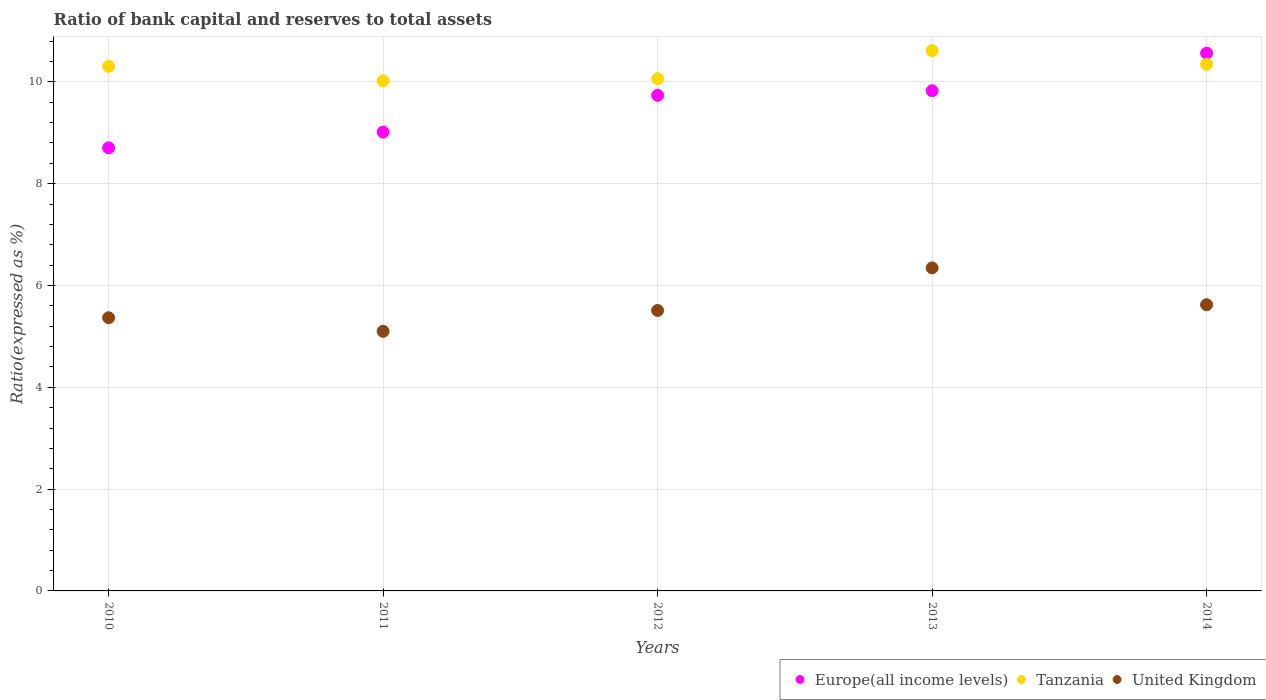Is the number of dotlines equal to the number of legend labels?
Provide a short and direct response. Yes. What is the ratio of bank capital and reserves to total assets in Europe(all income levels) in 2010?
Ensure brevity in your answer.  8.7. Across all years, what is the maximum ratio of bank capital and reserves to total assets in United Kingdom?
Make the answer very short. 6.35. Across all years, what is the minimum ratio of bank capital and reserves to total assets in Europe(all income levels)?
Provide a succinct answer. 8.7. In which year was the ratio of bank capital and reserves to total assets in United Kingdom maximum?
Offer a very short reply. 2013. In which year was the ratio of bank capital and reserves to total assets in Tanzania minimum?
Your answer should be very brief. 2011. What is the total ratio of bank capital and reserves to total assets in Europe(all income levels) in the graph?
Give a very brief answer. 47.84. What is the difference between the ratio of bank capital and reserves to total assets in Tanzania in 2010 and that in 2012?
Ensure brevity in your answer.  0.24. What is the difference between the ratio of bank capital and reserves to total assets in Tanzania in 2011 and the ratio of bank capital and reserves to total assets in United Kingdom in 2014?
Offer a terse response. 4.4. What is the average ratio of bank capital and reserves to total assets in Tanzania per year?
Offer a terse response. 10.27. In the year 2013, what is the difference between the ratio of bank capital and reserves to total assets in Tanzania and ratio of bank capital and reserves to total assets in United Kingdom?
Give a very brief answer. 4.27. What is the ratio of the ratio of bank capital and reserves to total assets in Europe(all income levels) in 2011 to that in 2012?
Give a very brief answer. 0.93. Is the difference between the ratio of bank capital and reserves to total assets in Tanzania in 2010 and 2013 greater than the difference between the ratio of bank capital and reserves to total assets in United Kingdom in 2010 and 2013?
Make the answer very short. Yes. What is the difference between the highest and the second highest ratio of bank capital and reserves to total assets in Tanzania?
Make the answer very short. 0.27. What is the difference between the highest and the lowest ratio of bank capital and reserves to total assets in Tanzania?
Your response must be concise. 0.59. In how many years, is the ratio of bank capital and reserves to total assets in Tanzania greater than the average ratio of bank capital and reserves to total assets in Tanzania taken over all years?
Provide a succinct answer. 3. Is the sum of the ratio of bank capital and reserves to total assets in Tanzania in 2012 and 2014 greater than the maximum ratio of bank capital and reserves to total assets in Europe(all income levels) across all years?
Ensure brevity in your answer.  Yes. Is it the case that in every year, the sum of the ratio of bank capital and reserves to total assets in Europe(all income levels) and ratio of bank capital and reserves to total assets in Tanzania  is greater than the ratio of bank capital and reserves to total assets in United Kingdom?
Your answer should be very brief. Yes. How many dotlines are there?
Offer a terse response. 3. How many years are there in the graph?
Your answer should be very brief. 5. Does the graph contain any zero values?
Offer a very short reply. No. How many legend labels are there?
Offer a very short reply. 3. What is the title of the graph?
Keep it short and to the point. Ratio of bank capital and reserves to total assets. What is the label or title of the Y-axis?
Keep it short and to the point. Ratio(expressed as %). What is the Ratio(expressed as %) in Europe(all income levels) in 2010?
Ensure brevity in your answer.  8.7. What is the Ratio(expressed as %) of Tanzania in 2010?
Ensure brevity in your answer.  10.3. What is the Ratio(expressed as %) in United Kingdom in 2010?
Offer a very short reply. 5.37. What is the Ratio(expressed as %) in Europe(all income levels) in 2011?
Ensure brevity in your answer.  9.01. What is the Ratio(expressed as %) of Tanzania in 2011?
Provide a succinct answer. 10.02. What is the Ratio(expressed as %) in United Kingdom in 2011?
Provide a succinct answer. 5.1. What is the Ratio(expressed as %) in Europe(all income levels) in 2012?
Ensure brevity in your answer.  9.74. What is the Ratio(expressed as %) of Tanzania in 2012?
Provide a short and direct response. 10.06. What is the Ratio(expressed as %) of United Kingdom in 2012?
Offer a terse response. 5.51. What is the Ratio(expressed as %) of Europe(all income levels) in 2013?
Ensure brevity in your answer.  9.83. What is the Ratio(expressed as %) in Tanzania in 2013?
Give a very brief answer. 10.61. What is the Ratio(expressed as %) in United Kingdom in 2013?
Your response must be concise. 6.35. What is the Ratio(expressed as %) in Europe(all income levels) in 2014?
Offer a very short reply. 10.56. What is the Ratio(expressed as %) in Tanzania in 2014?
Your answer should be very brief. 10.35. What is the Ratio(expressed as %) of United Kingdom in 2014?
Ensure brevity in your answer.  5.62. Across all years, what is the maximum Ratio(expressed as %) of Europe(all income levels)?
Make the answer very short. 10.56. Across all years, what is the maximum Ratio(expressed as %) of Tanzania?
Offer a very short reply. 10.61. Across all years, what is the maximum Ratio(expressed as %) in United Kingdom?
Provide a short and direct response. 6.35. Across all years, what is the minimum Ratio(expressed as %) in Europe(all income levels)?
Keep it short and to the point. 8.7. Across all years, what is the minimum Ratio(expressed as %) of Tanzania?
Provide a succinct answer. 10.02. Across all years, what is the minimum Ratio(expressed as %) in United Kingdom?
Keep it short and to the point. 5.1. What is the total Ratio(expressed as %) of Europe(all income levels) in the graph?
Your answer should be very brief. 47.84. What is the total Ratio(expressed as %) in Tanzania in the graph?
Give a very brief answer. 51.35. What is the total Ratio(expressed as %) in United Kingdom in the graph?
Offer a terse response. 27.94. What is the difference between the Ratio(expressed as %) in Europe(all income levels) in 2010 and that in 2011?
Provide a succinct answer. -0.31. What is the difference between the Ratio(expressed as %) of Tanzania in 2010 and that in 2011?
Your answer should be compact. 0.28. What is the difference between the Ratio(expressed as %) of United Kingdom in 2010 and that in 2011?
Give a very brief answer. 0.27. What is the difference between the Ratio(expressed as %) of Europe(all income levels) in 2010 and that in 2012?
Your answer should be compact. -1.03. What is the difference between the Ratio(expressed as %) in Tanzania in 2010 and that in 2012?
Keep it short and to the point. 0.24. What is the difference between the Ratio(expressed as %) in United Kingdom in 2010 and that in 2012?
Give a very brief answer. -0.14. What is the difference between the Ratio(expressed as %) in Europe(all income levels) in 2010 and that in 2013?
Offer a very short reply. -1.12. What is the difference between the Ratio(expressed as %) of Tanzania in 2010 and that in 2013?
Provide a succinct answer. -0.31. What is the difference between the Ratio(expressed as %) of United Kingdom in 2010 and that in 2013?
Provide a short and direct response. -0.98. What is the difference between the Ratio(expressed as %) of Europe(all income levels) in 2010 and that in 2014?
Give a very brief answer. -1.86. What is the difference between the Ratio(expressed as %) of Tanzania in 2010 and that in 2014?
Offer a terse response. -0.04. What is the difference between the Ratio(expressed as %) in United Kingdom in 2010 and that in 2014?
Offer a terse response. -0.26. What is the difference between the Ratio(expressed as %) of Europe(all income levels) in 2011 and that in 2012?
Provide a short and direct response. -0.72. What is the difference between the Ratio(expressed as %) of Tanzania in 2011 and that in 2012?
Give a very brief answer. -0.04. What is the difference between the Ratio(expressed as %) in United Kingdom in 2011 and that in 2012?
Provide a succinct answer. -0.41. What is the difference between the Ratio(expressed as %) of Europe(all income levels) in 2011 and that in 2013?
Make the answer very short. -0.81. What is the difference between the Ratio(expressed as %) of Tanzania in 2011 and that in 2013?
Keep it short and to the point. -0.59. What is the difference between the Ratio(expressed as %) of United Kingdom in 2011 and that in 2013?
Provide a short and direct response. -1.25. What is the difference between the Ratio(expressed as %) in Europe(all income levels) in 2011 and that in 2014?
Your response must be concise. -1.55. What is the difference between the Ratio(expressed as %) in Tanzania in 2011 and that in 2014?
Give a very brief answer. -0.33. What is the difference between the Ratio(expressed as %) in United Kingdom in 2011 and that in 2014?
Offer a terse response. -0.52. What is the difference between the Ratio(expressed as %) in Europe(all income levels) in 2012 and that in 2013?
Make the answer very short. -0.09. What is the difference between the Ratio(expressed as %) of Tanzania in 2012 and that in 2013?
Your response must be concise. -0.55. What is the difference between the Ratio(expressed as %) of United Kingdom in 2012 and that in 2013?
Give a very brief answer. -0.84. What is the difference between the Ratio(expressed as %) of Europe(all income levels) in 2012 and that in 2014?
Provide a succinct answer. -0.83. What is the difference between the Ratio(expressed as %) of Tanzania in 2012 and that in 2014?
Give a very brief answer. -0.28. What is the difference between the Ratio(expressed as %) in United Kingdom in 2012 and that in 2014?
Offer a terse response. -0.11. What is the difference between the Ratio(expressed as %) of Europe(all income levels) in 2013 and that in 2014?
Provide a succinct answer. -0.74. What is the difference between the Ratio(expressed as %) in Tanzania in 2013 and that in 2014?
Make the answer very short. 0.27. What is the difference between the Ratio(expressed as %) of United Kingdom in 2013 and that in 2014?
Provide a short and direct response. 0.72. What is the difference between the Ratio(expressed as %) in Europe(all income levels) in 2010 and the Ratio(expressed as %) in Tanzania in 2011?
Your answer should be very brief. -1.32. What is the difference between the Ratio(expressed as %) of Europe(all income levels) in 2010 and the Ratio(expressed as %) of United Kingdom in 2011?
Give a very brief answer. 3.6. What is the difference between the Ratio(expressed as %) of Tanzania in 2010 and the Ratio(expressed as %) of United Kingdom in 2011?
Ensure brevity in your answer.  5.2. What is the difference between the Ratio(expressed as %) in Europe(all income levels) in 2010 and the Ratio(expressed as %) in Tanzania in 2012?
Provide a succinct answer. -1.36. What is the difference between the Ratio(expressed as %) of Europe(all income levels) in 2010 and the Ratio(expressed as %) of United Kingdom in 2012?
Offer a very short reply. 3.2. What is the difference between the Ratio(expressed as %) in Tanzania in 2010 and the Ratio(expressed as %) in United Kingdom in 2012?
Offer a terse response. 4.8. What is the difference between the Ratio(expressed as %) of Europe(all income levels) in 2010 and the Ratio(expressed as %) of Tanzania in 2013?
Provide a succinct answer. -1.91. What is the difference between the Ratio(expressed as %) of Europe(all income levels) in 2010 and the Ratio(expressed as %) of United Kingdom in 2013?
Your response must be concise. 2.36. What is the difference between the Ratio(expressed as %) of Tanzania in 2010 and the Ratio(expressed as %) of United Kingdom in 2013?
Provide a succinct answer. 3.96. What is the difference between the Ratio(expressed as %) of Europe(all income levels) in 2010 and the Ratio(expressed as %) of Tanzania in 2014?
Provide a succinct answer. -1.64. What is the difference between the Ratio(expressed as %) of Europe(all income levels) in 2010 and the Ratio(expressed as %) of United Kingdom in 2014?
Offer a terse response. 3.08. What is the difference between the Ratio(expressed as %) of Tanzania in 2010 and the Ratio(expressed as %) of United Kingdom in 2014?
Your answer should be compact. 4.68. What is the difference between the Ratio(expressed as %) in Europe(all income levels) in 2011 and the Ratio(expressed as %) in Tanzania in 2012?
Provide a short and direct response. -1.05. What is the difference between the Ratio(expressed as %) in Europe(all income levels) in 2011 and the Ratio(expressed as %) in United Kingdom in 2012?
Your answer should be compact. 3.5. What is the difference between the Ratio(expressed as %) in Tanzania in 2011 and the Ratio(expressed as %) in United Kingdom in 2012?
Provide a short and direct response. 4.51. What is the difference between the Ratio(expressed as %) in Europe(all income levels) in 2011 and the Ratio(expressed as %) in Tanzania in 2013?
Your response must be concise. -1.6. What is the difference between the Ratio(expressed as %) in Europe(all income levels) in 2011 and the Ratio(expressed as %) in United Kingdom in 2013?
Make the answer very short. 2.67. What is the difference between the Ratio(expressed as %) in Tanzania in 2011 and the Ratio(expressed as %) in United Kingdom in 2013?
Give a very brief answer. 3.67. What is the difference between the Ratio(expressed as %) in Europe(all income levels) in 2011 and the Ratio(expressed as %) in Tanzania in 2014?
Keep it short and to the point. -1.33. What is the difference between the Ratio(expressed as %) of Europe(all income levels) in 2011 and the Ratio(expressed as %) of United Kingdom in 2014?
Your response must be concise. 3.39. What is the difference between the Ratio(expressed as %) of Tanzania in 2011 and the Ratio(expressed as %) of United Kingdom in 2014?
Give a very brief answer. 4.4. What is the difference between the Ratio(expressed as %) in Europe(all income levels) in 2012 and the Ratio(expressed as %) in Tanzania in 2013?
Provide a short and direct response. -0.88. What is the difference between the Ratio(expressed as %) of Europe(all income levels) in 2012 and the Ratio(expressed as %) of United Kingdom in 2013?
Your answer should be very brief. 3.39. What is the difference between the Ratio(expressed as %) in Tanzania in 2012 and the Ratio(expressed as %) in United Kingdom in 2013?
Provide a short and direct response. 3.72. What is the difference between the Ratio(expressed as %) in Europe(all income levels) in 2012 and the Ratio(expressed as %) in Tanzania in 2014?
Provide a short and direct response. -0.61. What is the difference between the Ratio(expressed as %) in Europe(all income levels) in 2012 and the Ratio(expressed as %) in United Kingdom in 2014?
Your answer should be very brief. 4.11. What is the difference between the Ratio(expressed as %) in Tanzania in 2012 and the Ratio(expressed as %) in United Kingdom in 2014?
Provide a succinct answer. 4.44. What is the difference between the Ratio(expressed as %) of Europe(all income levels) in 2013 and the Ratio(expressed as %) of Tanzania in 2014?
Keep it short and to the point. -0.52. What is the difference between the Ratio(expressed as %) of Europe(all income levels) in 2013 and the Ratio(expressed as %) of United Kingdom in 2014?
Provide a short and direct response. 4.2. What is the difference between the Ratio(expressed as %) in Tanzania in 2013 and the Ratio(expressed as %) in United Kingdom in 2014?
Your answer should be very brief. 4.99. What is the average Ratio(expressed as %) in Europe(all income levels) per year?
Ensure brevity in your answer.  9.57. What is the average Ratio(expressed as %) in Tanzania per year?
Ensure brevity in your answer.  10.27. What is the average Ratio(expressed as %) of United Kingdom per year?
Provide a succinct answer. 5.59. In the year 2010, what is the difference between the Ratio(expressed as %) in Europe(all income levels) and Ratio(expressed as %) in Tanzania?
Keep it short and to the point. -1.6. In the year 2010, what is the difference between the Ratio(expressed as %) in Europe(all income levels) and Ratio(expressed as %) in United Kingdom?
Offer a terse response. 3.34. In the year 2010, what is the difference between the Ratio(expressed as %) of Tanzania and Ratio(expressed as %) of United Kingdom?
Make the answer very short. 4.94. In the year 2011, what is the difference between the Ratio(expressed as %) in Europe(all income levels) and Ratio(expressed as %) in Tanzania?
Offer a very short reply. -1.01. In the year 2011, what is the difference between the Ratio(expressed as %) in Europe(all income levels) and Ratio(expressed as %) in United Kingdom?
Provide a succinct answer. 3.91. In the year 2011, what is the difference between the Ratio(expressed as %) in Tanzania and Ratio(expressed as %) in United Kingdom?
Offer a very short reply. 4.92. In the year 2012, what is the difference between the Ratio(expressed as %) of Europe(all income levels) and Ratio(expressed as %) of Tanzania?
Give a very brief answer. -0.33. In the year 2012, what is the difference between the Ratio(expressed as %) in Europe(all income levels) and Ratio(expressed as %) in United Kingdom?
Offer a terse response. 4.23. In the year 2012, what is the difference between the Ratio(expressed as %) of Tanzania and Ratio(expressed as %) of United Kingdom?
Provide a short and direct response. 4.55. In the year 2013, what is the difference between the Ratio(expressed as %) of Europe(all income levels) and Ratio(expressed as %) of Tanzania?
Offer a very short reply. -0.79. In the year 2013, what is the difference between the Ratio(expressed as %) of Europe(all income levels) and Ratio(expressed as %) of United Kingdom?
Offer a terse response. 3.48. In the year 2013, what is the difference between the Ratio(expressed as %) of Tanzania and Ratio(expressed as %) of United Kingdom?
Your response must be concise. 4.27. In the year 2014, what is the difference between the Ratio(expressed as %) in Europe(all income levels) and Ratio(expressed as %) in Tanzania?
Your answer should be very brief. 0.22. In the year 2014, what is the difference between the Ratio(expressed as %) of Europe(all income levels) and Ratio(expressed as %) of United Kingdom?
Provide a succinct answer. 4.94. In the year 2014, what is the difference between the Ratio(expressed as %) in Tanzania and Ratio(expressed as %) in United Kingdom?
Give a very brief answer. 4.72. What is the ratio of the Ratio(expressed as %) of Europe(all income levels) in 2010 to that in 2011?
Provide a succinct answer. 0.97. What is the ratio of the Ratio(expressed as %) in Tanzania in 2010 to that in 2011?
Ensure brevity in your answer.  1.03. What is the ratio of the Ratio(expressed as %) in United Kingdom in 2010 to that in 2011?
Provide a succinct answer. 1.05. What is the ratio of the Ratio(expressed as %) of Europe(all income levels) in 2010 to that in 2012?
Your response must be concise. 0.89. What is the ratio of the Ratio(expressed as %) in Tanzania in 2010 to that in 2012?
Your response must be concise. 1.02. What is the ratio of the Ratio(expressed as %) of United Kingdom in 2010 to that in 2012?
Make the answer very short. 0.97. What is the ratio of the Ratio(expressed as %) in Europe(all income levels) in 2010 to that in 2013?
Offer a very short reply. 0.89. What is the ratio of the Ratio(expressed as %) in Tanzania in 2010 to that in 2013?
Your answer should be compact. 0.97. What is the ratio of the Ratio(expressed as %) of United Kingdom in 2010 to that in 2013?
Make the answer very short. 0.85. What is the ratio of the Ratio(expressed as %) of Europe(all income levels) in 2010 to that in 2014?
Provide a succinct answer. 0.82. What is the ratio of the Ratio(expressed as %) of United Kingdom in 2010 to that in 2014?
Keep it short and to the point. 0.95. What is the ratio of the Ratio(expressed as %) in Europe(all income levels) in 2011 to that in 2012?
Keep it short and to the point. 0.93. What is the ratio of the Ratio(expressed as %) in Tanzania in 2011 to that in 2012?
Your answer should be very brief. 1. What is the ratio of the Ratio(expressed as %) of United Kingdom in 2011 to that in 2012?
Ensure brevity in your answer.  0.93. What is the ratio of the Ratio(expressed as %) in Europe(all income levels) in 2011 to that in 2013?
Make the answer very short. 0.92. What is the ratio of the Ratio(expressed as %) in Tanzania in 2011 to that in 2013?
Your answer should be very brief. 0.94. What is the ratio of the Ratio(expressed as %) in United Kingdom in 2011 to that in 2013?
Offer a terse response. 0.8. What is the ratio of the Ratio(expressed as %) of Europe(all income levels) in 2011 to that in 2014?
Make the answer very short. 0.85. What is the ratio of the Ratio(expressed as %) in Tanzania in 2011 to that in 2014?
Offer a very short reply. 0.97. What is the ratio of the Ratio(expressed as %) of United Kingdom in 2011 to that in 2014?
Ensure brevity in your answer.  0.91. What is the ratio of the Ratio(expressed as %) in Tanzania in 2012 to that in 2013?
Your response must be concise. 0.95. What is the ratio of the Ratio(expressed as %) in United Kingdom in 2012 to that in 2013?
Your answer should be compact. 0.87. What is the ratio of the Ratio(expressed as %) of Europe(all income levels) in 2012 to that in 2014?
Provide a succinct answer. 0.92. What is the ratio of the Ratio(expressed as %) in Tanzania in 2012 to that in 2014?
Make the answer very short. 0.97. What is the ratio of the Ratio(expressed as %) in United Kingdom in 2012 to that in 2014?
Give a very brief answer. 0.98. What is the ratio of the Ratio(expressed as %) of Europe(all income levels) in 2013 to that in 2014?
Keep it short and to the point. 0.93. What is the ratio of the Ratio(expressed as %) in Tanzania in 2013 to that in 2014?
Your response must be concise. 1.03. What is the ratio of the Ratio(expressed as %) in United Kingdom in 2013 to that in 2014?
Your answer should be compact. 1.13. What is the difference between the highest and the second highest Ratio(expressed as %) in Europe(all income levels)?
Your response must be concise. 0.74. What is the difference between the highest and the second highest Ratio(expressed as %) in Tanzania?
Your answer should be compact. 0.27. What is the difference between the highest and the second highest Ratio(expressed as %) of United Kingdom?
Provide a short and direct response. 0.72. What is the difference between the highest and the lowest Ratio(expressed as %) of Europe(all income levels)?
Ensure brevity in your answer.  1.86. What is the difference between the highest and the lowest Ratio(expressed as %) in Tanzania?
Provide a succinct answer. 0.59. What is the difference between the highest and the lowest Ratio(expressed as %) in United Kingdom?
Ensure brevity in your answer.  1.25. 